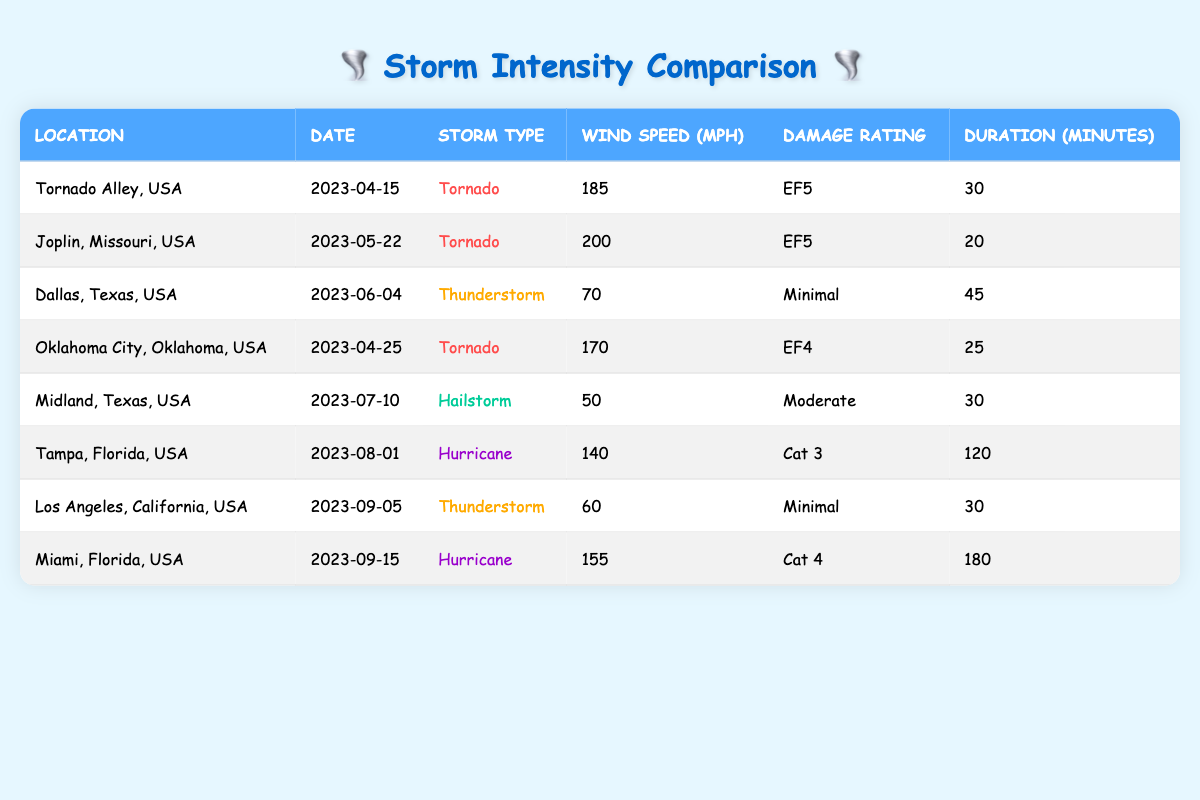What is the highest wind speed recorded in the table? The highest wind speed is listed under the Tornado entry for Joplin, Missouri, which is 200 mph.
Answer: 200 mph How long did the Hurricane in Miami last? The duration of the Hurricane in Miami is marked as 180 minutes in the table.
Answer: 180 minutes Which storm had a damage rating of EF4 or higher? The Tornado in Tornado Alley (EF5), the Tornado in Joplin (EF5), and the Tornado in Oklahoma City (EF4) all have ratings of EF4 or higher.
Answer: Tornado Alley, Joplin, Oklahoma City What is the average wind speed of the thunderstorms listed? The wind speeds for the thunderstorms in Dallas (70 mph) and Los Angeles (60 mph) sum up to 130 mph. The average wind speed is therefore 130/2 = 65 mph.
Answer: 65 mph Did the Tornadoes last longer than the Hurricanes? The longest Tornado lasted 30 minutes (Tornado Alley), and the Hurricanes lasted 120 minutes (Tampa) and 180 minutes (Miami), thus, the Tornadoes did not last longer.
Answer: No Which storm type caused the most significant damage based on the ratings? Only Tornadoes (EF5 and EF4 ratings) indicate severe damage, while all other types (Minimal and Moderate) are rated lower. Therefore, Tornadoes caused the most significant damage.
Answer: Tornadoes How many more minutes did the Hurricane in Tampa last compared to the Tornado in Oklahoma City? The Hurricane in Tampa lasted 120 minutes while the Tornado in Oklahoma City lasted 25 minutes. Taking the difference gives 120 - 25 = 95 minutes.
Answer: 95 minutes Are there any storms with a damage rating of "Cat 3"? The data includes one storm with a damage rating of "Cat 3," which is the Hurricane in Tampa, Florida.
Answer: Yes Which location experienced two types of storms, and what were those types? Dallas, Texas experienced a Thunderstorm and Midland, Texas experienced a Hailstorm. Therefore, Dallas and Midland both have two different storm types listed.
Answer: Dallas (Thunderstorm), Midland (Hailstorm) 